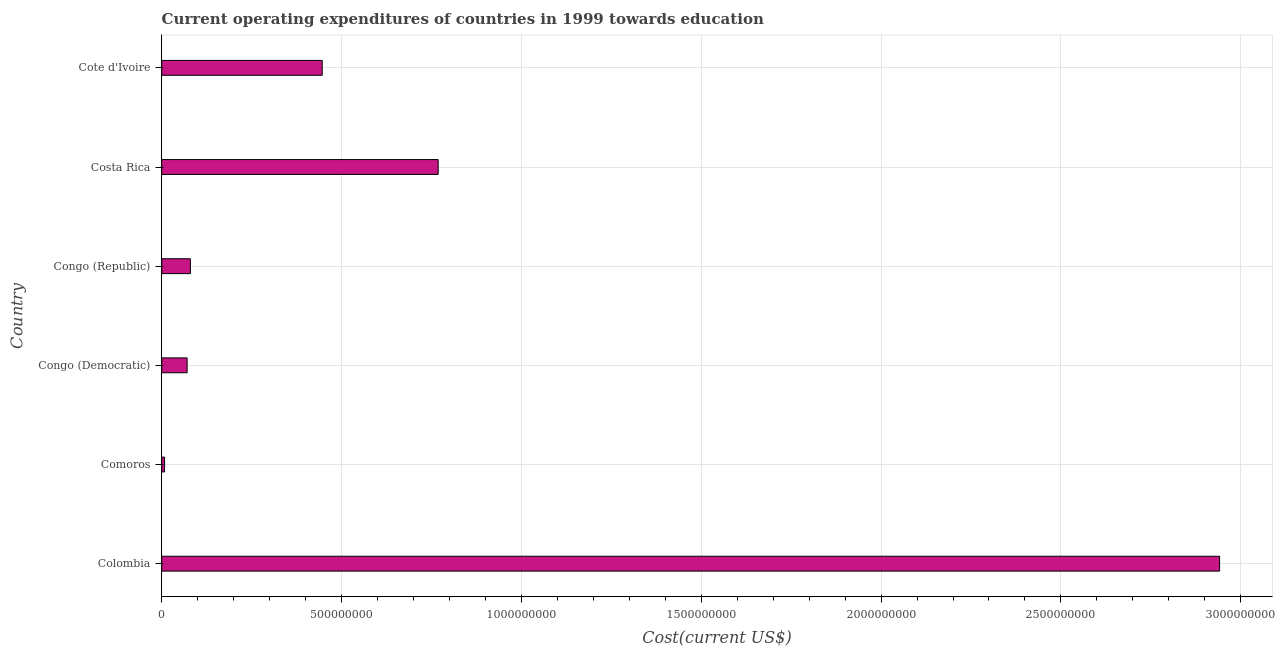Does the graph contain any zero values?
Ensure brevity in your answer.  No. What is the title of the graph?
Ensure brevity in your answer.  Current operating expenditures of countries in 1999 towards education. What is the label or title of the X-axis?
Provide a short and direct response. Cost(current US$). What is the education expenditure in Costa Rica?
Offer a terse response. 7.69e+08. Across all countries, what is the maximum education expenditure?
Offer a terse response. 2.94e+09. Across all countries, what is the minimum education expenditure?
Make the answer very short. 7.93e+06. In which country was the education expenditure minimum?
Make the answer very short. Comoros. What is the sum of the education expenditure?
Offer a very short reply. 4.31e+09. What is the difference between the education expenditure in Costa Rica and Cote d'Ivoire?
Keep it short and to the point. 3.22e+08. What is the average education expenditure per country?
Provide a succinct answer. 7.19e+08. What is the median education expenditure?
Offer a terse response. 2.63e+08. What is the ratio of the education expenditure in Comoros to that in Cote d'Ivoire?
Offer a terse response. 0.02. What is the difference between the highest and the second highest education expenditure?
Keep it short and to the point. 2.17e+09. What is the difference between the highest and the lowest education expenditure?
Offer a terse response. 2.93e+09. In how many countries, is the education expenditure greater than the average education expenditure taken over all countries?
Keep it short and to the point. 2. How many bars are there?
Ensure brevity in your answer.  6. Are all the bars in the graph horizontal?
Offer a terse response. Yes. How many countries are there in the graph?
Provide a succinct answer. 6. What is the difference between two consecutive major ticks on the X-axis?
Your response must be concise. 5.00e+08. What is the Cost(current US$) of Colombia?
Your answer should be compact. 2.94e+09. What is the Cost(current US$) in Comoros?
Make the answer very short. 7.93e+06. What is the Cost(current US$) of Congo (Democratic)?
Your response must be concise. 7.06e+07. What is the Cost(current US$) in Congo (Republic)?
Offer a very short reply. 7.98e+07. What is the Cost(current US$) of Costa Rica?
Give a very brief answer. 7.69e+08. What is the Cost(current US$) of Cote d'Ivoire?
Provide a short and direct response. 4.46e+08. What is the difference between the Cost(current US$) in Colombia and Comoros?
Offer a terse response. 2.93e+09. What is the difference between the Cost(current US$) in Colombia and Congo (Democratic)?
Your answer should be compact. 2.87e+09. What is the difference between the Cost(current US$) in Colombia and Congo (Republic)?
Keep it short and to the point. 2.86e+09. What is the difference between the Cost(current US$) in Colombia and Costa Rica?
Your answer should be very brief. 2.17e+09. What is the difference between the Cost(current US$) in Colombia and Cote d'Ivoire?
Keep it short and to the point. 2.49e+09. What is the difference between the Cost(current US$) in Comoros and Congo (Democratic)?
Your answer should be very brief. -6.27e+07. What is the difference between the Cost(current US$) in Comoros and Congo (Republic)?
Make the answer very short. -7.18e+07. What is the difference between the Cost(current US$) in Comoros and Costa Rica?
Your answer should be very brief. -7.61e+08. What is the difference between the Cost(current US$) in Comoros and Cote d'Ivoire?
Ensure brevity in your answer.  -4.38e+08. What is the difference between the Cost(current US$) in Congo (Democratic) and Congo (Republic)?
Your answer should be very brief. -9.14e+06. What is the difference between the Cost(current US$) in Congo (Democratic) and Costa Rica?
Provide a succinct answer. -6.98e+08. What is the difference between the Cost(current US$) in Congo (Democratic) and Cote d'Ivoire?
Offer a very short reply. -3.76e+08. What is the difference between the Cost(current US$) in Congo (Republic) and Costa Rica?
Provide a succinct answer. -6.89e+08. What is the difference between the Cost(current US$) in Congo (Republic) and Cote d'Ivoire?
Offer a very short reply. -3.66e+08. What is the difference between the Cost(current US$) in Costa Rica and Cote d'Ivoire?
Provide a short and direct response. 3.22e+08. What is the ratio of the Cost(current US$) in Colombia to that in Comoros?
Provide a succinct answer. 370.7. What is the ratio of the Cost(current US$) in Colombia to that in Congo (Democratic)?
Provide a succinct answer. 41.63. What is the ratio of the Cost(current US$) in Colombia to that in Congo (Republic)?
Provide a succinct answer. 36.87. What is the ratio of the Cost(current US$) in Colombia to that in Costa Rica?
Offer a terse response. 3.83. What is the ratio of the Cost(current US$) in Colombia to that in Cote d'Ivoire?
Make the answer very short. 6.59. What is the ratio of the Cost(current US$) in Comoros to that in Congo (Democratic)?
Ensure brevity in your answer.  0.11. What is the ratio of the Cost(current US$) in Comoros to that in Congo (Republic)?
Your answer should be very brief. 0.1. What is the ratio of the Cost(current US$) in Comoros to that in Cote d'Ivoire?
Offer a terse response. 0.02. What is the ratio of the Cost(current US$) in Congo (Democratic) to that in Congo (Republic)?
Your answer should be compact. 0.89. What is the ratio of the Cost(current US$) in Congo (Democratic) to that in Costa Rica?
Provide a succinct answer. 0.09. What is the ratio of the Cost(current US$) in Congo (Democratic) to that in Cote d'Ivoire?
Provide a short and direct response. 0.16. What is the ratio of the Cost(current US$) in Congo (Republic) to that in Costa Rica?
Offer a terse response. 0.1. What is the ratio of the Cost(current US$) in Congo (Republic) to that in Cote d'Ivoire?
Make the answer very short. 0.18. What is the ratio of the Cost(current US$) in Costa Rica to that in Cote d'Ivoire?
Offer a terse response. 1.72. 